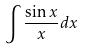<formula> <loc_0><loc_0><loc_500><loc_500>\int \frac { \sin x } { x } d x</formula> 